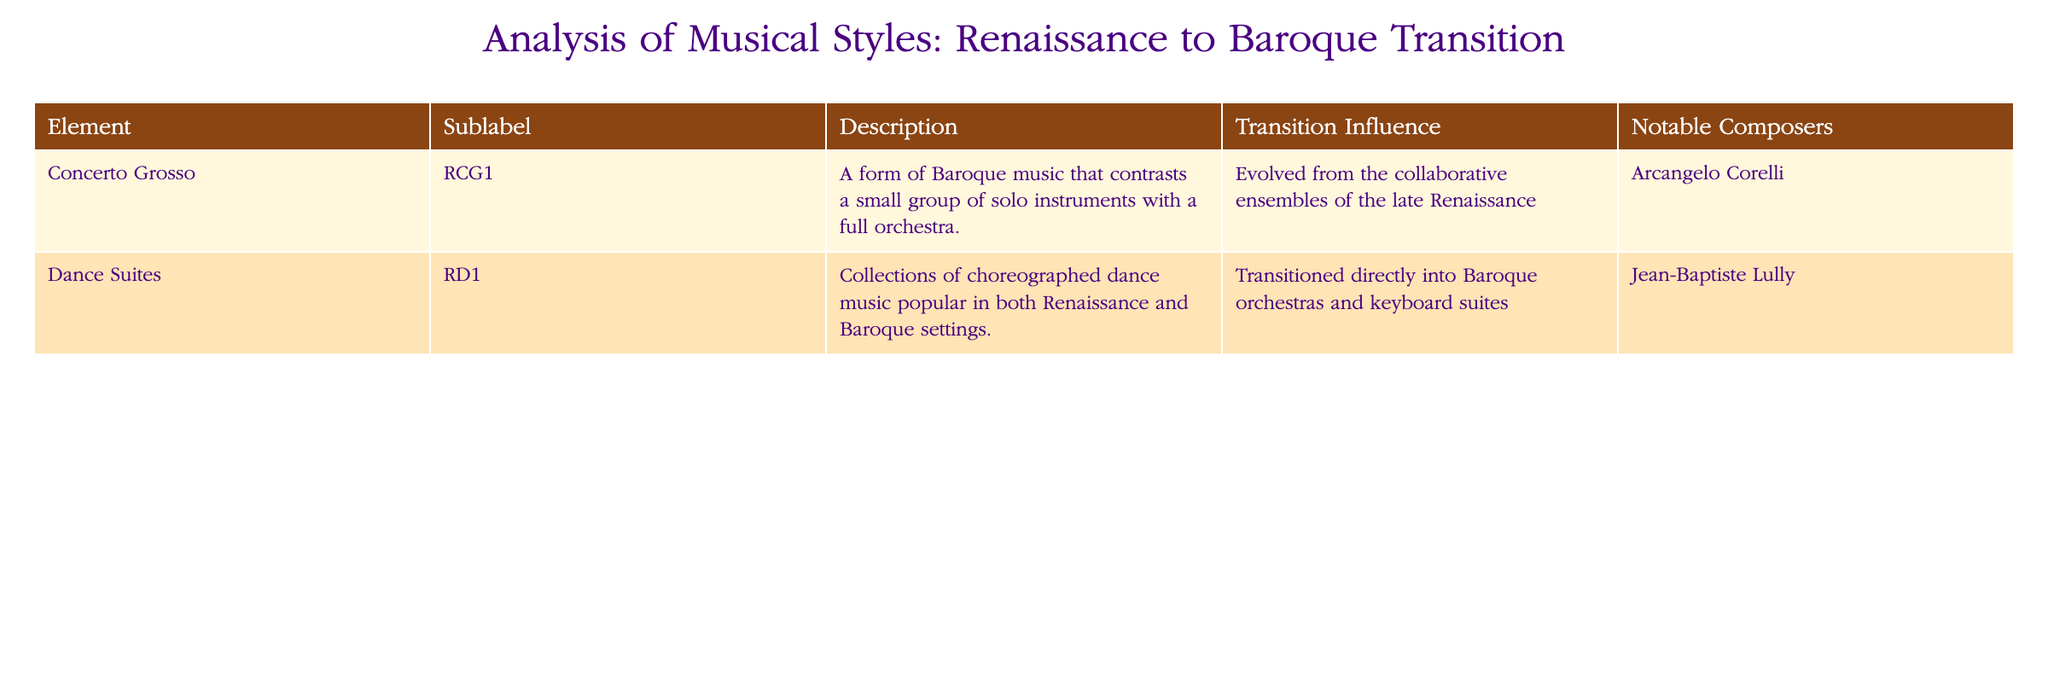What is the description of the Concerto Grosso? The description for the Concerto Grosso is found in the "Description" column of the table. It states that it is "A form of Baroque music that contrasts a small group of solo instruments with a full orchestra."
Answer: A form of Baroque music that contrasts a small group of solo instruments with a full orchestra Who is the notable composer associated with Dance Suites? The table lists the notable composers in the "Notable Composers" column. For Dance Suites, it states that Jean-Baptiste Lully is the associated composer.
Answer: Jean-Baptiste Lully Did the Concerto Grosso evolve from Renaissance music? To answer this yes or no question, we look at the "Transition Influence" column for Concerto Grosso, which mentions that it evolved from the collaborative ensembles of the late Renaissance. Therefore, it is true.
Answer: Yes What can you say about how Dance Suites transitioned into the Baroque period? Reviewing the "Transition Influence" column for Dance Suites indicates that they transitioned directly into Baroque orchestras and keyboard suites. This suggests a significant continuity and adaptation of the dance forms into the Baroque orchestras.
Answer: They transitioned directly into Baroque orchestras and keyboard suites Which music style had two notable influences mentioned in this table? Looking at the table, only the Concerto Grosso has a detailed "Transition Influence" that describes its evolution from Renaissance music explicitly. The Dance Suites also mention their transition, but it doesn't elaborate on influences, making Concerto Grosso the focus.
Answer: Concerto Grosso 